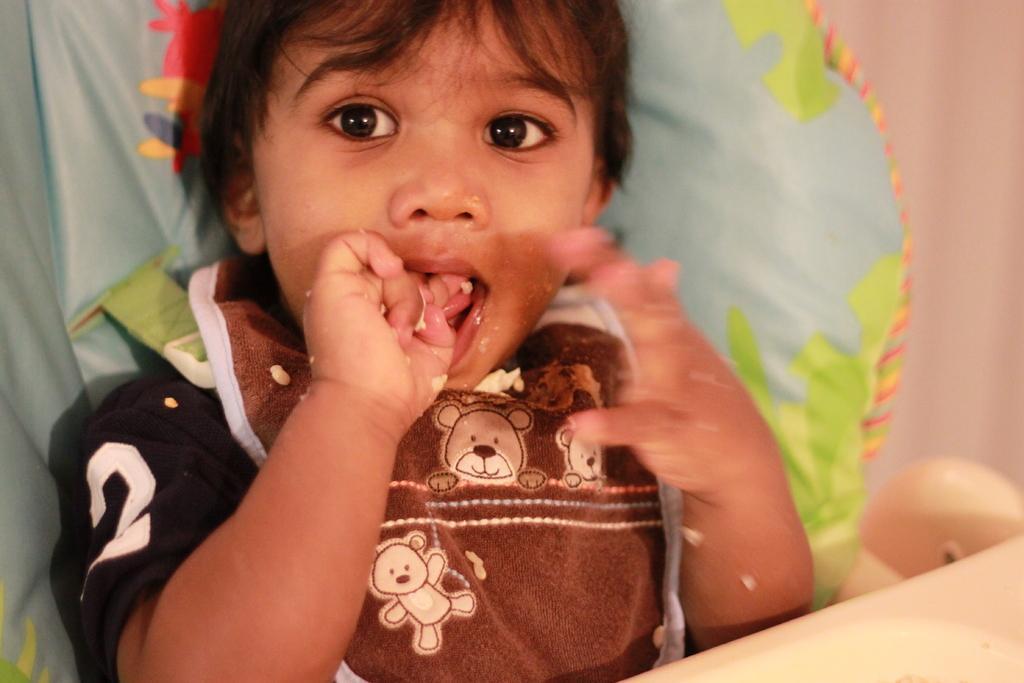Describe this image in one or two sentences. Here I can see a baby in a baby chair. This baby is wearing a t-shirt and looking at the picture. The background is blurred. In the bottom right-hand corner there is an object. 